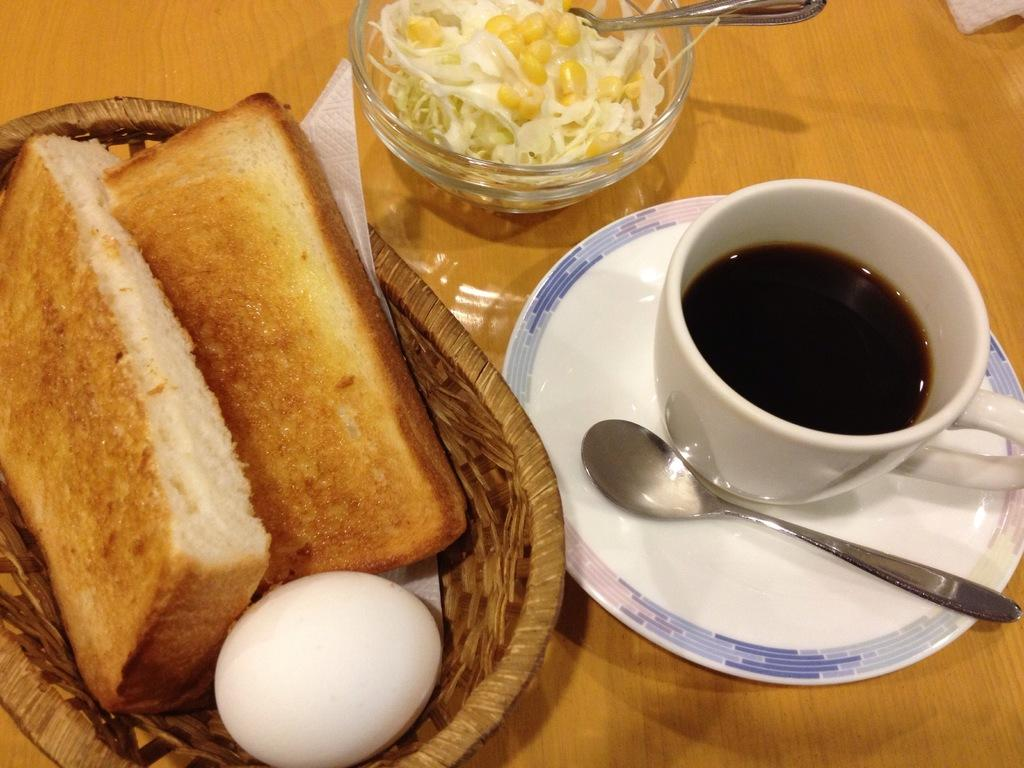What is in the cup that is visible in the image? There is a cup with liquid in the image. What other items can be seen in the image? There is a plate, a spoon, a bowl with food, bread, and an egg visible in the image. What type of container is present in the image? There is a basket in the image. What hobbies are the people in the image participating in? There are no people visible in the image, so it is not possible to determine their hobbies. Can you see a kite in the image? No, there is no kite present in the image. 